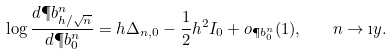Convert formula to latex. <formula><loc_0><loc_0><loc_500><loc_500>\log \frac { d \P b ^ { n } _ { h / \sqrt { n } } } { d \P b ^ { n } _ { 0 } } = h \Delta _ { n , 0 } - \frac { 1 } { 2 } h ^ { 2 } I _ { 0 } + o _ { \P b ^ { n } _ { 0 } } ( 1 ) , \quad n \to \i y .</formula> 